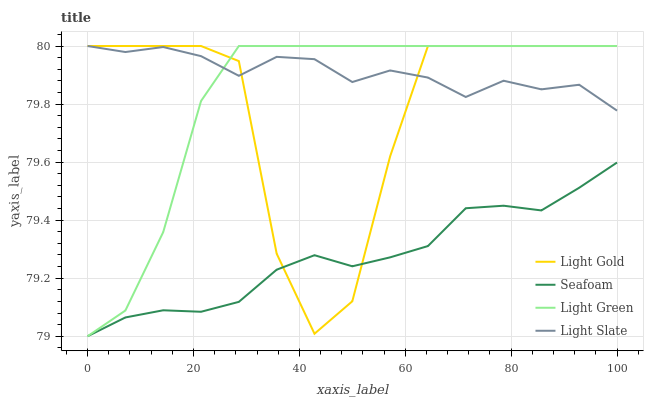Does Seafoam have the minimum area under the curve?
Answer yes or no. Yes. Does Light Slate have the maximum area under the curve?
Answer yes or no. Yes. Does Light Gold have the minimum area under the curve?
Answer yes or no. No. Does Light Gold have the maximum area under the curve?
Answer yes or no. No. Is Seafoam the smoothest?
Answer yes or no. Yes. Is Light Gold the roughest?
Answer yes or no. Yes. Is Light Gold the smoothest?
Answer yes or no. No. Is Seafoam the roughest?
Answer yes or no. No. Does Seafoam have the lowest value?
Answer yes or no. Yes. Does Light Gold have the lowest value?
Answer yes or no. No. Does Light Green have the highest value?
Answer yes or no. Yes. Does Seafoam have the highest value?
Answer yes or no. No. Is Seafoam less than Light Slate?
Answer yes or no. Yes. Is Light Green greater than Seafoam?
Answer yes or no. Yes. Does Light Gold intersect Seafoam?
Answer yes or no. Yes. Is Light Gold less than Seafoam?
Answer yes or no. No. Is Light Gold greater than Seafoam?
Answer yes or no. No. Does Seafoam intersect Light Slate?
Answer yes or no. No. 